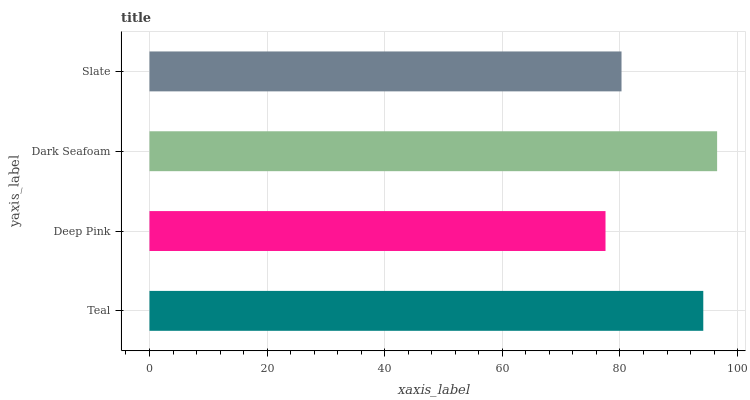Is Deep Pink the minimum?
Answer yes or no. Yes. Is Dark Seafoam the maximum?
Answer yes or no. Yes. Is Dark Seafoam the minimum?
Answer yes or no. No. Is Deep Pink the maximum?
Answer yes or no. No. Is Dark Seafoam greater than Deep Pink?
Answer yes or no. Yes. Is Deep Pink less than Dark Seafoam?
Answer yes or no. Yes. Is Deep Pink greater than Dark Seafoam?
Answer yes or no. No. Is Dark Seafoam less than Deep Pink?
Answer yes or no. No. Is Teal the high median?
Answer yes or no. Yes. Is Slate the low median?
Answer yes or no. Yes. Is Deep Pink the high median?
Answer yes or no. No. Is Deep Pink the low median?
Answer yes or no. No. 